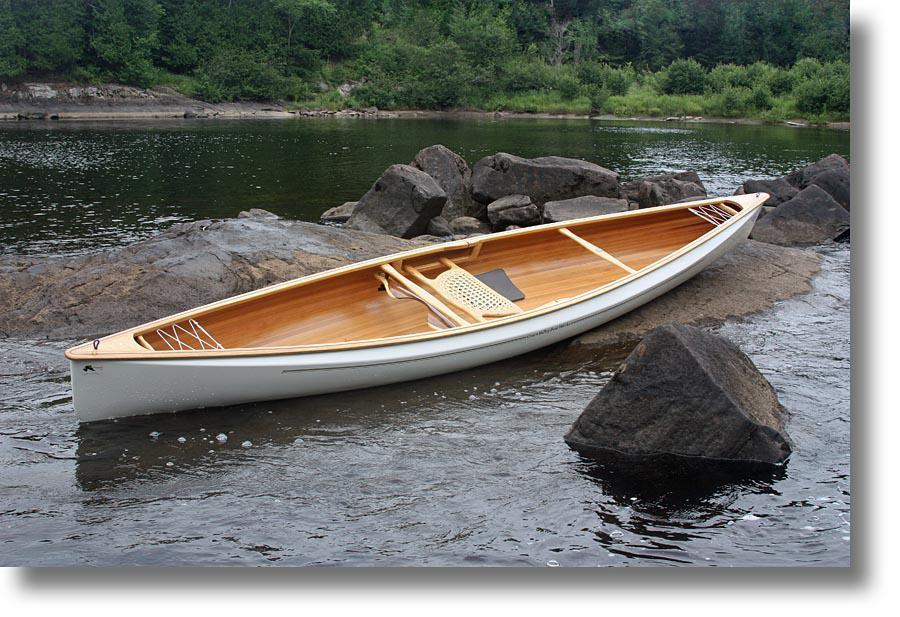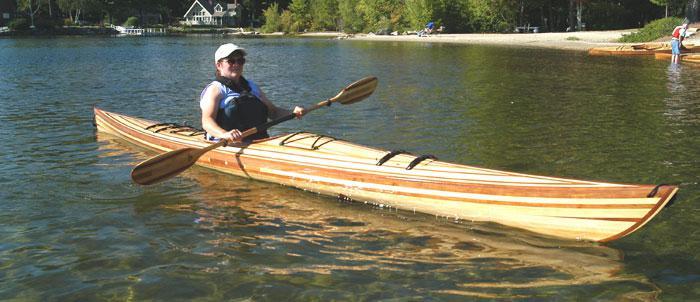The first image is the image on the left, the second image is the image on the right. Analyze the images presented: Is the assertion "One image shows a person on a boat in the water, and the other image shows a white canoe pulled up out of the water near gray boulders." valid? Answer yes or no. Yes. The first image is the image on the left, the second image is the image on the right. Considering the images on both sides, is "In one image, there is a white canoe resting slightly on its side on a large rocky area in the middle of a body of water" valid? Answer yes or no. Yes. 